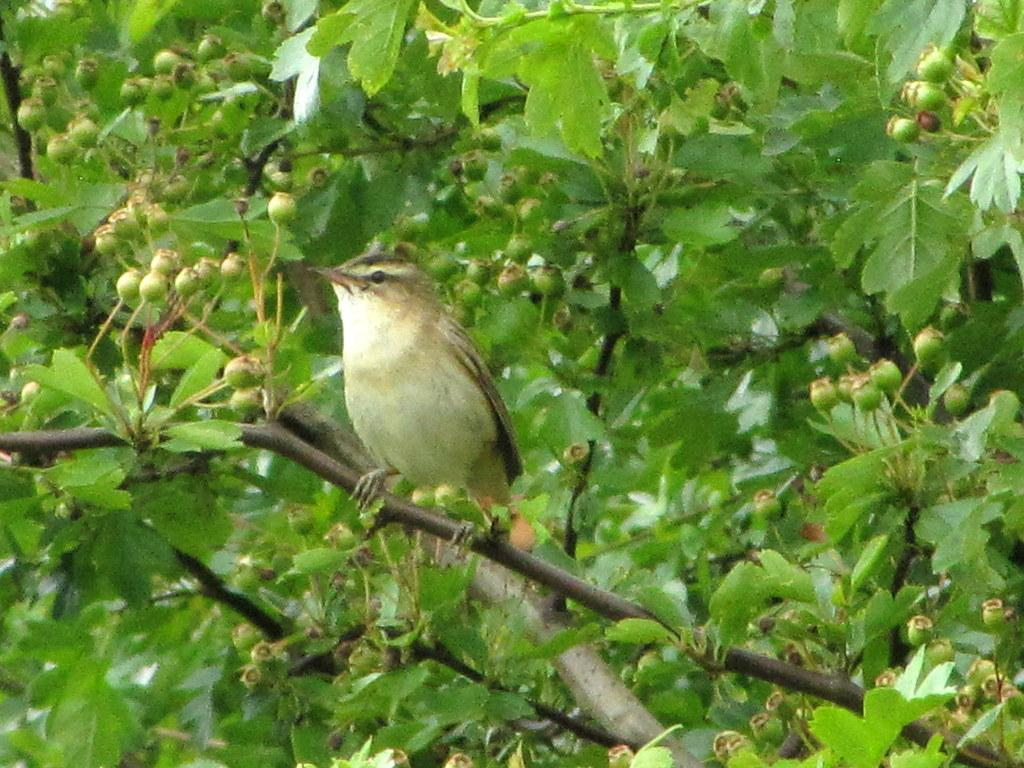What type of animal is in the image? There is a bird in the image. Where is the bird located? The bird is on a tree branch. What else can be seen on the tree in the image? There are leaves in the image. Are there any signs of new growth on the tree? Yes, there are buds in the image. What type of reward does the frog receive for sitting on the branch in the image? There is no frog present in the image, so there is no reward being given. 